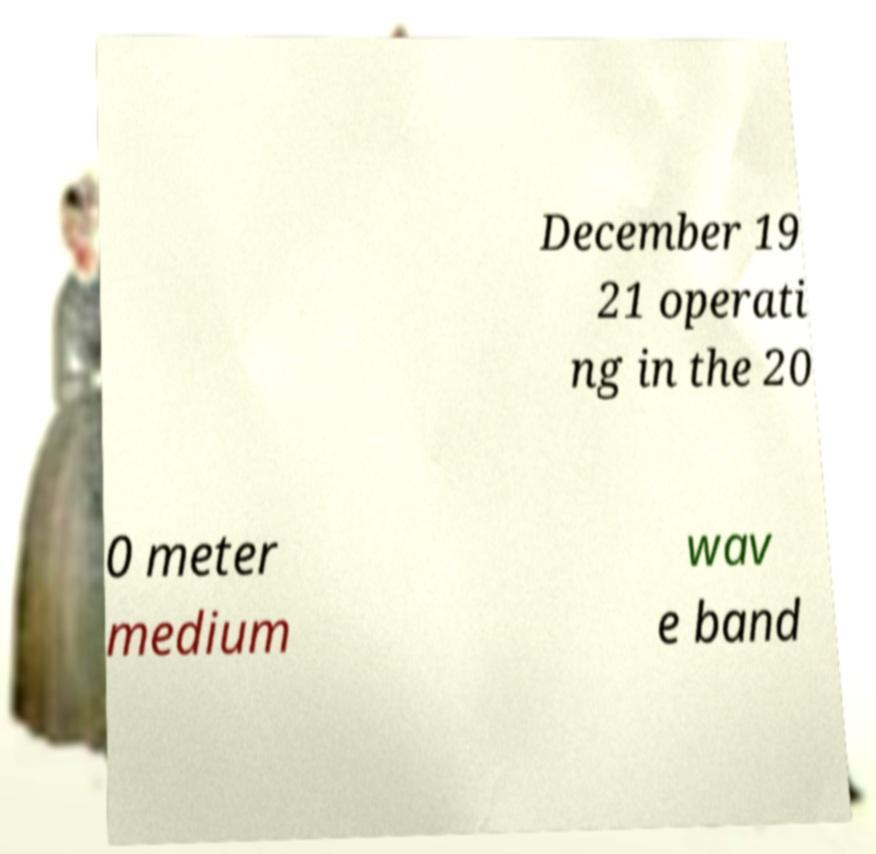There's text embedded in this image that I need extracted. Can you transcribe it verbatim? December 19 21 operati ng in the 20 0 meter medium wav e band 